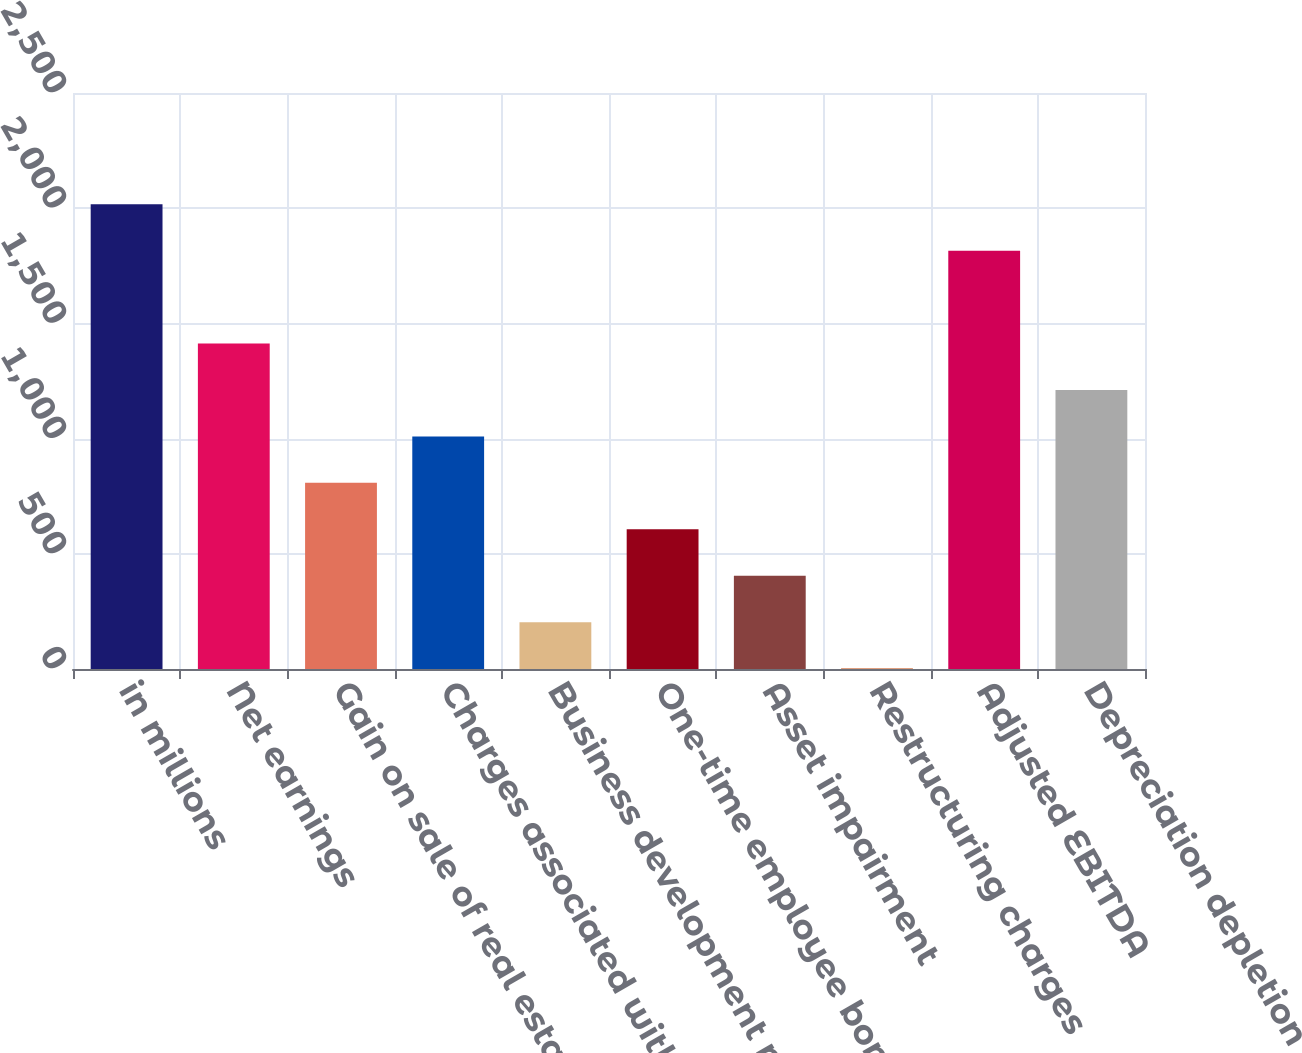<chart> <loc_0><loc_0><loc_500><loc_500><bar_chart><fcel>in millions<fcel>Net earnings<fcel>Gain on sale of real estate<fcel>Charges associated with<fcel>Business development net of<fcel>One-time employee bonuses<fcel>Asset impairment<fcel>Restructuring charges<fcel>Adjusted EBITDA<fcel>Depreciation depletion<nl><fcel>2017<fcel>1412.47<fcel>807.94<fcel>1009.45<fcel>203.41<fcel>606.43<fcel>404.92<fcel>1.9<fcel>1815.49<fcel>1210.96<nl></chart> 